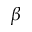<formula> <loc_0><loc_0><loc_500><loc_500>\beta</formula> 